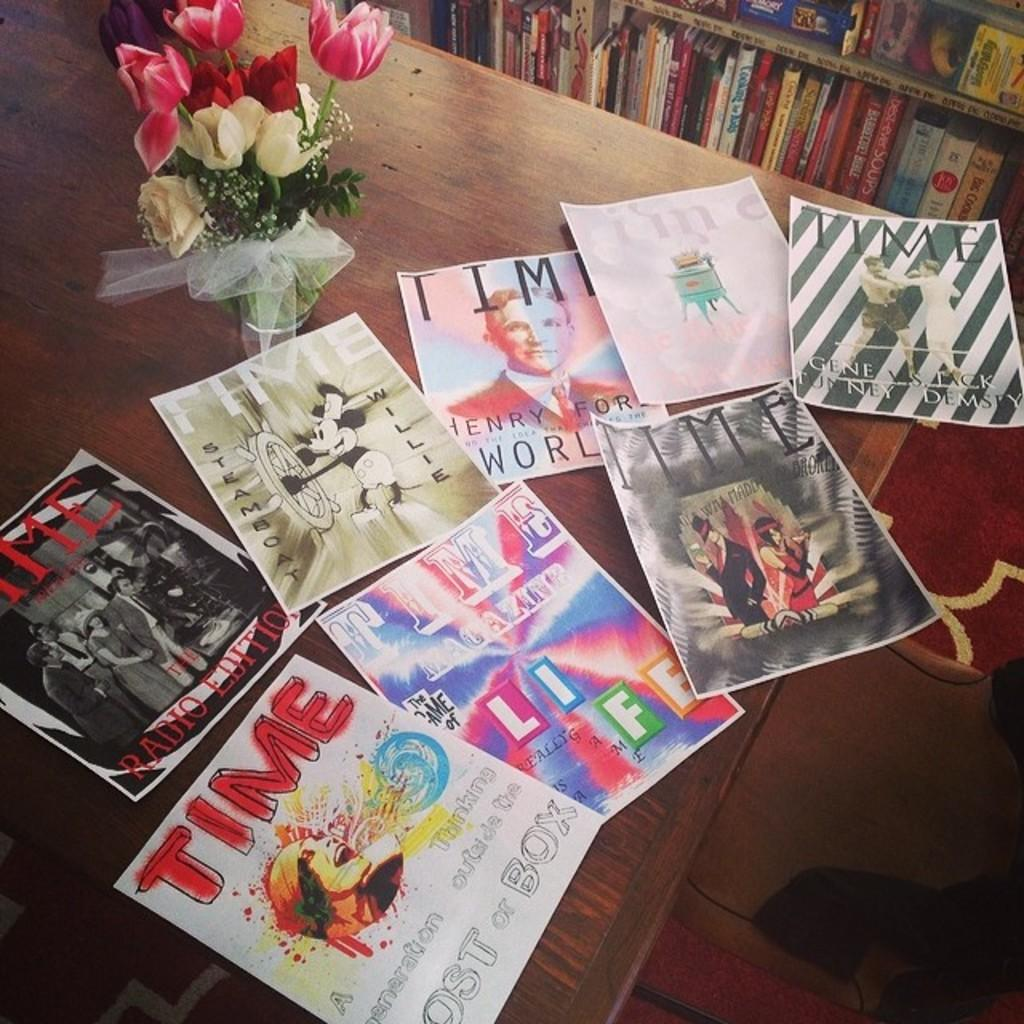<image>
Offer a succinct explanation of the picture presented. Several TIME magazine cover drawings laid out on a table. 